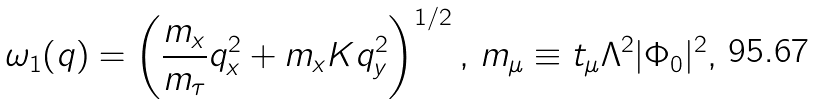<formula> <loc_0><loc_0><loc_500><loc_500>\omega _ { 1 } ( { q } ) = \left ( \frac { m _ { x } } { m _ { \tau } } q _ { x } ^ { 2 } + m _ { x } K q _ { y } ^ { 2 } \right ) ^ { 1 / 2 } , \, m _ { \mu } \equiv t _ { \mu } \Lambda ^ { 2 } | \Phi _ { 0 } | ^ { 2 } ,</formula> 